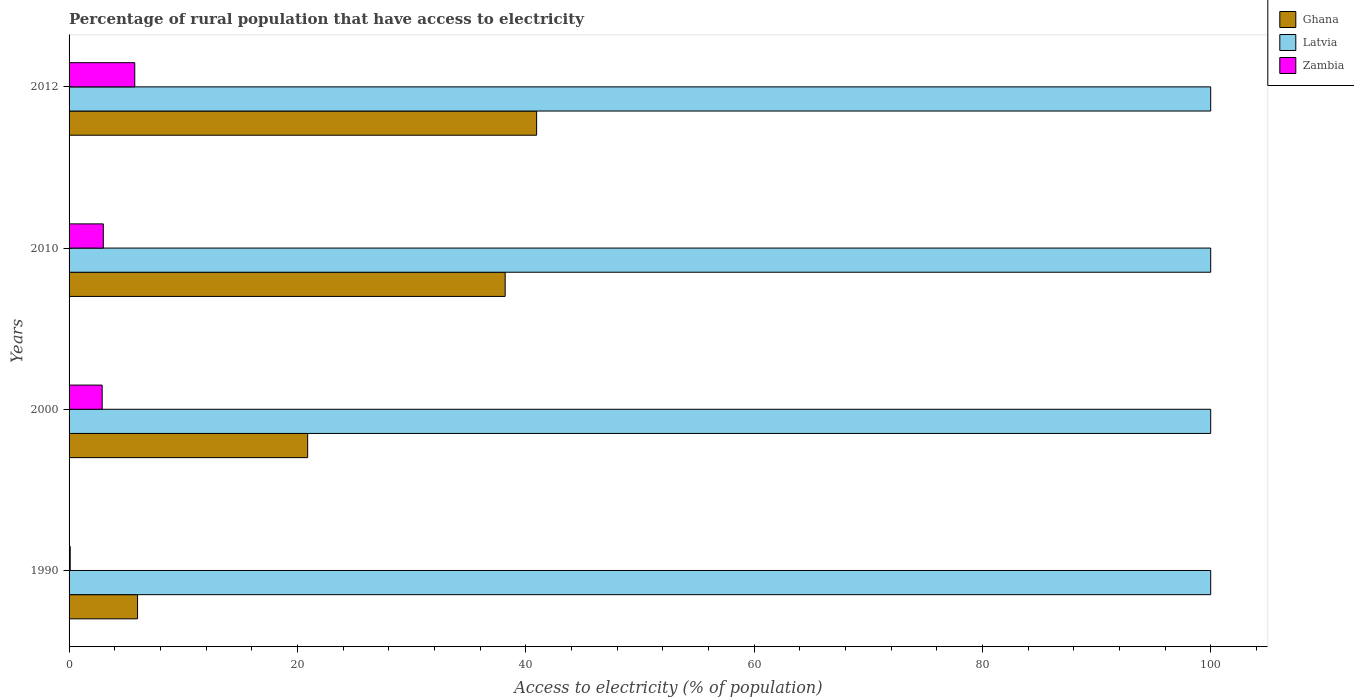How many groups of bars are there?
Your answer should be compact. 4. Are the number of bars per tick equal to the number of legend labels?
Provide a short and direct response. Yes. What is the percentage of rural population that have access to electricity in Ghana in 1990?
Offer a very short reply. 6. Across all years, what is the maximum percentage of rural population that have access to electricity in Latvia?
Offer a terse response. 100. Across all years, what is the minimum percentage of rural population that have access to electricity in Latvia?
Offer a terse response. 100. In which year was the percentage of rural population that have access to electricity in Ghana maximum?
Your response must be concise. 2012. What is the total percentage of rural population that have access to electricity in Zambia in the graph?
Provide a succinct answer. 11.75. What is the difference between the percentage of rural population that have access to electricity in Latvia in 1990 and that in 2000?
Give a very brief answer. 0. What is the difference between the percentage of rural population that have access to electricity in Latvia in 2010 and the percentage of rural population that have access to electricity in Zambia in 2012?
Provide a short and direct response. 94.25. What is the average percentage of rural population that have access to electricity in Ghana per year?
Your answer should be very brief. 26.51. In the year 2000, what is the difference between the percentage of rural population that have access to electricity in Ghana and percentage of rural population that have access to electricity in Latvia?
Provide a short and direct response. -79.1. What is the ratio of the percentage of rural population that have access to electricity in Zambia in 2000 to that in 2010?
Offer a terse response. 0.97. What is the difference between the highest and the second highest percentage of rural population that have access to electricity in Zambia?
Ensure brevity in your answer.  2.75. What is the difference between the highest and the lowest percentage of rural population that have access to electricity in Zambia?
Provide a short and direct response. 5.65. In how many years, is the percentage of rural population that have access to electricity in Zambia greater than the average percentage of rural population that have access to electricity in Zambia taken over all years?
Your answer should be compact. 2. What does the 1st bar from the top in 2000 represents?
Your response must be concise. Zambia. What does the 1st bar from the bottom in 1990 represents?
Provide a short and direct response. Ghana. Is it the case that in every year, the sum of the percentage of rural population that have access to electricity in Latvia and percentage of rural population that have access to electricity in Ghana is greater than the percentage of rural population that have access to electricity in Zambia?
Ensure brevity in your answer.  Yes. How many bars are there?
Your answer should be compact. 12. How many years are there in the graph?
Provide a short and direct response. 4. What is the difference between two consecutive major ticks on the X-axis?
Provide a short and direct response. 20. Does the graph contain any zero values?
Keep it short and to the point. No. Where does the legend appear in the graph?
Keep it short and to the point. Top right. How are the legend labels stacked?
Your answer should be compact. Vertical. What is the title of the graph?
Your response must be concise. Percentage of rural population that have access to electricity. Does "Ukraine" appear as one of the legend labels in the graph?
Your response must be concise. No. What is the label or title of the X-axis?
Your response must be concise. Access to electricity (% of population). What is the Access to electricity (% of population) of Ghana in 1990?
Offer a terse response. 6. What is the Access to electricity (% of population) of Ghana in 2000?
Keep it short and to the point. 20.9. What is the Access to electricity (% of population) in Latvia in 2000?
Provide a short and direct response. 100. What is the Access to electricity (% of population) of Zambia in 2000?
Offer a terse response. 2.9. What is the Access to electricity (% of population) in Ghana in 2010?
Ensure brevity in your answer.  38.2. What is the Access to electricity (% of population) of Latvia in 2010?
Keep it short and to the point. 100. What is the Access to electricity (% of population) of Zambia in 2010?
Your answer should be very brief. 3. What is the Access to electricity (% of population) of Ghana in 2012?
Keep it short and to the point. 40.95. What is the Access to electricity (% of population) in Zambia in 2012?
Keep it short and to the point. 5.75. Across all years, what is the maximum Access to electricity (% of population) in Ghana?
Your response must be concise. 40.95. Across all years, what is the maximum Access to electricity (% of population) of Zambia?
Provide a succinct answer. 5.75. Across all years, what is the minimum Access to electricity (% of population) in Latvia?
Your answer should be compact. 100. What is the total Access to electricity (% of population) of Ghana in the graph?
Give a very brief answer. 106.05. What is the total Access to electricity (% of population) of Zambia in the graph?
Make the answer very short. 11.75. What is the difference between the Access to electricity (% of population) of Ghana in 1990 and that in 2000?
Offer a very short reply. -14.9. What is the difference between the Access to electricity (% of population) in Latvia in 1990 and that in 2000?
Your response must be concise. 0. What is the difference between the Access to electricity (% of population) in Zambia in 1990 and that in 2000?
Make the answer very short. -2.8. What is the difference between the Access to electricity (% of population) of Ghana in 1990 and that in 2010?
Your answer should be very brief. -32.2. What is the difference between the Access to electricity (% of population) in Zambia in 1990 and that in 2010?
Your answer should be very brief. -2.9. What is the difference between the Access to electricity (% of population) of Ghana in 1990 and that in 2012?
Provide a short and direct response. -34.95. What is the difference between the Access to electricity (% of population) of Latvia in 1990 and that in 2012?
Give a very brief answer. 0. What is the difference between the Access to electricity (% of population) of Zambia in 1990 and that in 2012?
Provide a short and direct response. -5.65. What is the difference between the Access to electricity (% of population) in Ghana in 2000 and that in 2010?
Make the answer very short. -17.3. What is the difference between the Access to electricity (% of population) in Zambia in 2000 and that in 2010?
Provide a succinct answer. -0.1. What is the difference between the Access to electricity (% of population) of Ghana in 2000 and that in 2012?
Your answer should be compact. -20.05. What is the difference between the Access to electricity (% of population) in Latvia in 2000 and that in 2012?
Your answer should be very brief. 0. What is the difference between the Access to electricity (% of population) in Zambia in 2000 and that in 2012?
Give a very brief answer. -2.85. What is the difference between the Access to electricity (% of population) in Ghana in 2010 and that in 2012?
Provide a short and direct response. -2.75. What is the difference between the Access to electricity (% of population) of Latvia in 2010 and that in 2012?
Your answer should be very brief. 0. What is the difference between the Access to electricity (% of population) of Zambia in 2010 and that in 2012?
Give a very brief answer. -2.75. What is the difference between the Access to electricity (% of population) in Ghana in 1990 and the Access to electricity (% of population) in Latvia in 2000?
Offer a very short reply. -94. What is the difference between the Access to electricity (% of population) in Latvia in 1990 and the Access to electricity (% of population) in Zambia in 2000?
Give a very brief answer. 97.1. What is the difference between the Access to electricity (% of population) in Ghana in 1990 and the Access to electricity (% of population) in Latvia in 2010?
Your answer should be very brief. -94. What is the difference between the Access to electricity (% of population) in Latvia in 1990 and the Access to electricity (% of population) in Zambia in 2010?
Provide a short and direct response. 97. What is the difference between the Access to electricity (% of population) of Ghana in 1990 and the Access to electricity (% of population) of Latvia in 2012?
Provide a succinct answer. -94. What is the difference between the Access to electricity (% of population) of Ghana in 1990 and the Access to electricity (% of population) of Zambia in 2012?
Offer a very short reply. 0.25. What is the difference between the Access to electricity (% of population) in Latvia in 1990 and the Access to electricity (% of population) in Zambia in 2012?
Ensure brevity in your answer.  94.25. What is the difference between the Access to electricity (% of population) of Ghana in 2000 and the Access to electricity (% of population) of Latvia in 2010?
Your response must be concise. -79.1. What is the difference between the Access to electricity (% of population) of Ghana in 2000 and the Access to electricity (% of population) of Zambia in 2010?
Ensure brevity in your answer.  17.9. What is the difference between the Access to electricity (% of population) of Latvia in 2000 and the Access to electricity (% of population) of Zambia in 2010?
Ensure brevity in your answer.  97. What is the difference between the Access to electricity (% of population) in Ghana in 2000 and the Access to electricity (% of population) in Latvia in 2012?
Keep it short and to the point. -79.1. What is the difference between the Access to electricity (% of population) in Ghana in 2000 and the Access to electricity (% of population) in Zambia in 2012?
Make the answer very short. 15.15. What is the difference between the Access to electricity (% of population) in Latvia in 2000 and the Access to electricity (% of population) in Zambia in 2012?
Offer a terse response. 94.25. What is the difference between the Access to electricity (% of population) of Ghana in 2010 and the Access to electricity (% of population) of Latvia in 2012?
Offer a very short reply. -61.8. What is the difference between the Access to electricity (% of population) of Ghana in 2010 and the Access to electricity (% of population) of Zambia in 2012?
Give a very brief answer. 32.45. What is the difference between the Access to electricity (% of population) in Latvia in 2010 and the Access to electricity (% of population) in Zambia in 2012?
Ensure brevity in your answer.  94.25. What is the average Access to electricity (% of population) in Ghana per year?
Give a very brief answer. 26.51. What is the average Access to electricity (% of population) in Zambia per year?
Give a very brief answer. 2.94. In the year 1990, what is the difference between the Access to electricity (% of population) in Ghana and Access to electricity (% of population) in Latvia?
Your answer should be very brief. -94. In the year 1990, what is the difference between the Access to electricity (% of population) of Ghana and Access to electricity (% of population) of Zambia?
Offer a very short reply. 5.9. In the year 1990, what is the difference between the Access to electricity (% of population) of Latvia and Access to electricity (% of population) of Zambia?
Provide a succinct answer. 99.9. In the year 2000, what is the difference between the Access to electricity (% of population) of Ghana and Access to electricity (% of population) of Latvia?
Ensure brevity in your answer.  -79.1. In the year 2000, what is the difference between the Access to electricity (% of population) in Ghana and Access to electricity (% of population) in Zambia?
Offer a terse response. 18. In the year 2000, what is the difference between the Access to electricity (% of population) in Latvia and Access to electricity (% of population) in Zambia?
Offer a terse response. 97.1. In the year 2010, what is the difference between the Access to electricity (% of population) in Ghana and Access to electricity (% of population) in Latvia?
Ensure brevity in your answer.  -61.8. In the year 2010, what is the difference between the Access to electricity (% of population) in Ghana and Access to electricity (% of population) in Zambia?
Your answer should be very brief. 35.2. In the year 2010, what is the difference between the Access to electricity (% of population) of Latvia and Access to electricity (% of population) of Zambia?
Your answer should be very brief. 97. In the year 2012, what is the difference between the Access to electricity (% of population) in Ghana and Access to electricity (% of population) in Latvia?
Your response must be concise. -59.05. In the year 2012, what is the difference between the Access to electricity (% of population) in Ghana and Access to electricity (% of population) in Zambia?
Ensure brevity in your answer.  35.2. In the year 2012, what is the difference between the Access to electricity (% of population) in Latvia and Access to electricity (% of population) in Zambia?
Keep it short and to the point. 94.25. What is the ratio of the Access to electricity (% of population) of Ghana in 1990 to that in 2000?
Your answer should be very brief. 0.29. What is the ratio of the Access to electricity (% of population) in Latvia in 1990 to that in 2000?
Provide a succinct answer. 1. What is the ratio of the Access to electricity (% of population) in Zambia in 1990 to that in 2000?
Make the answer very short. 0.03. What is the ratio of the Access to electricity (% of population) of Ghana in 1990 to that in 2010?
Provide a short and direct response. 0.16. What is the ratio of the Access to electricity (% of population) of Latvia in 1990 to that in 2010?
Your answer should be very brief. 1. What is the ratio of the Access to electricity (% of population) in Zambia in 1990 to that in 2010?
Your answer should be very brief. 0.03. What is the ratio of the Access to electricity (% of population) of Ghana in 1990 to that in 2012?
Your response must be concise. 0.15. What is the ratio of the Access to electricity (% of population) of Zambia in 1990 to that in 2012?
Keep it short and to the point. 0.02. What is the ratio of the Access to electricity (% of population) in Ghana in 2000 to that in 2010?
Offer a very short reply. 0.55. What is the ratio of the Access to electricity (% of population) in Zambia in 2000 to that in 2010?
Your answer should be compact. 0.97. What is the ratio of the Access to electricity (% of population) in Ghana in 2000 to that in 2012?
Make the answer very short. 0.51. What is the ratio of the Access to electricity (% of population) of Zambia in 2000 to that in 2012?
Your response must be concise. 0.5. What is the ratio of the Access to electricity (% of population) in Ghana in 2010 to that in 2012?
Provide a succinct answer. 0.93. What is the ratio of the Access to electricity (% of population) in Latvia in 2010 to that in 2012?
Offer a very short reply. 1. What is the ratio of the Access to electricity (% of population) in Zambia in 2010 to that in 2012?
Provide a succinct answer. 0.52. What is the difference between the highest and the second highest Access to electricity (% of population) of Ghana?
Offer a terse response. 2.75. What is the difference between the highest and the second highest Access to electricity (% of population) of Zambia?
Give a very brief answer. 2.75. What is the difference between the highest and the lowest Access to electricity (% of population) of Ghana?
Offer a very short reply. 34.95. What is the difference between the highest and the lowest Access to electricity (% of population) of Zambia?
Offer a terse response. 5.65. 